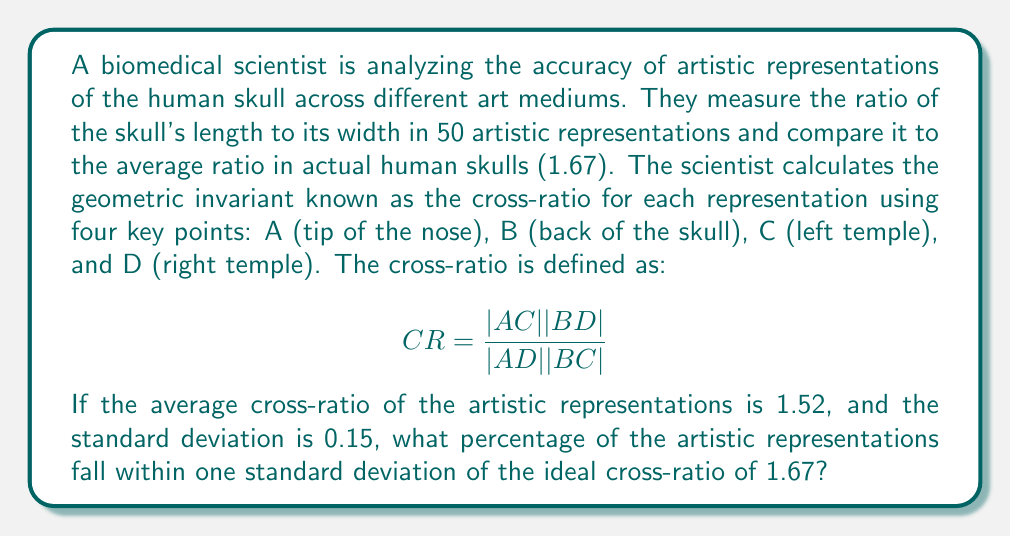Provide a solution to this math problem. To solve this problem, we'll follow these steps:

1) First, we need to determine the range of cross-ratios that fall within one standard deviation of the ideal.

   Lower bound: $1.67 - 0.15 = 1.52$
   Upper bound: $1.67 + 0.15 = 1.82$

2) Now, we need to find how many standard deviations these bounds are from the mean of the artistic representations.

   For the lower bound:
   $z_1 = \frac{1.52 - 1.52}{0.15} = 0$

   For the upper bound:
   $z_2 = \frac{1.82 - 1.52}{0.15} = 2$

3) We can use the standard normal distribution to find the probability of a value falling between these z-scores.

   The probability of a value falling between 0 and 2 standard deviations above the mean is:
   $P(0 < Z < 2) = 0.4772$ (from a standard normal table)

4) Since the distribution is symmetric, we need to double this probability to account for values below the mean as well.

   Total probability: $2 * 0.4772 = 0.9544$

5) Convert this probability to a percentage:

   $0.9544 * 100\% = 95.44\%$

Therefore, approximately 95.44% of the artistic representations fall within one standard deviation of the ideal cross-ratio.
Answer: 95.44% 